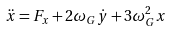Convert formula to latex. <formula><loc_0><loc_0><loc_500><loc_500>\ddot { x } = F _ { x } + 2 \omega _ { G } \dot { y } + 3 \omega _ { G } ^ { 2 } x</formula> 